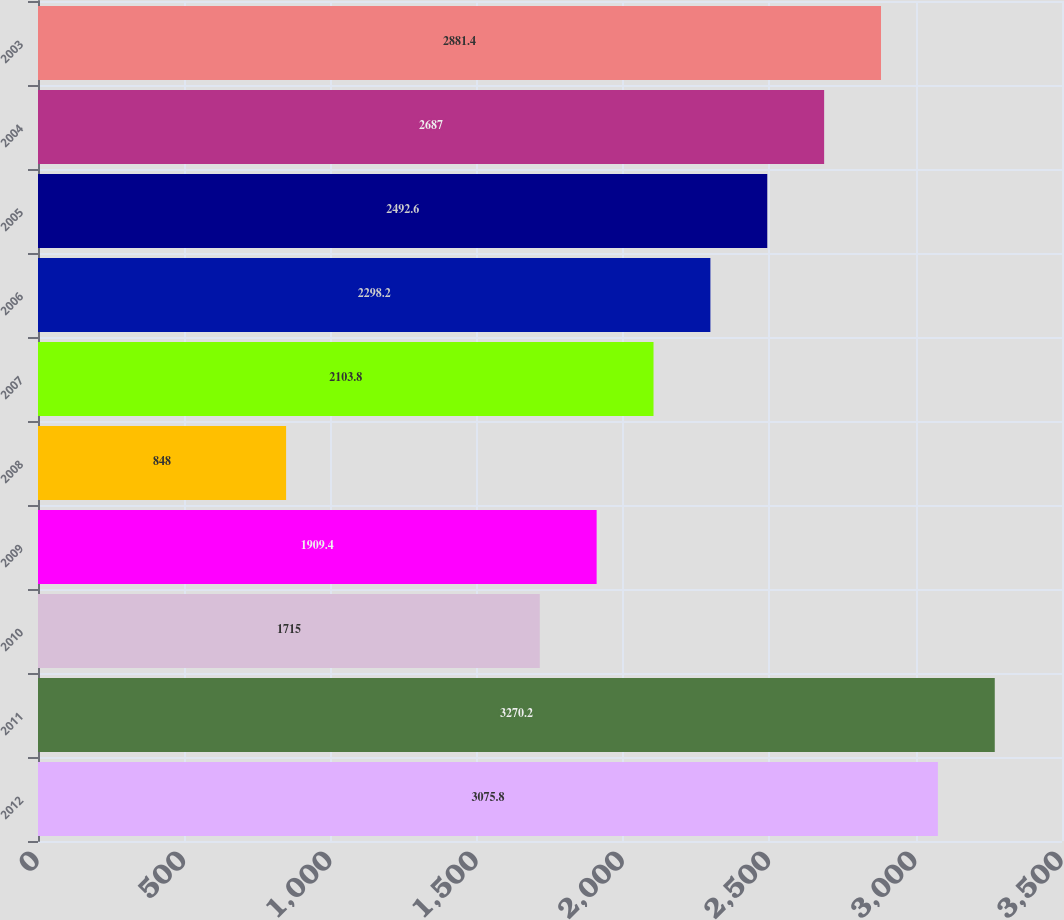Convert chart to OTSL. <chart><loc_0><loc_0><loc_500><loc_500><bar_chart><fcel>2012<fcel>2011<fcel>2010<fcel>2009<fcel>2008<fcel>2007<fcel>2006<fcel>2005<fcel>2004<fcel>2003<nl><fcel>3075.8<fcel>3270.2<fcel>1715<fcel>1909.4<fcel>848<fcel>2103.8<fcel>2298.2<fcel>2492.6<fcel>2687<fcel>2881.4<nl></chart> 